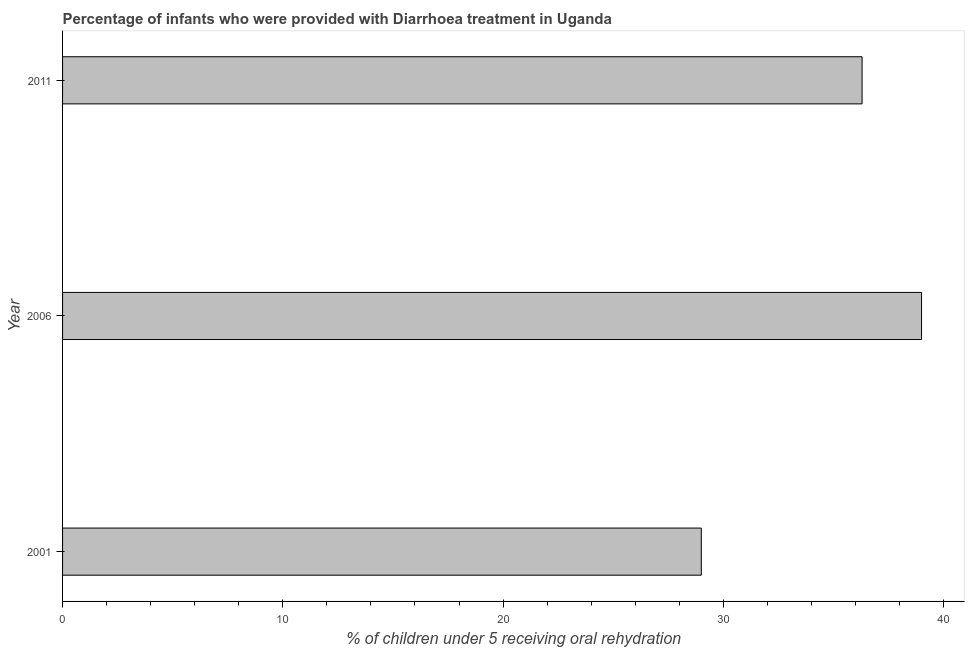Does the graph contain grids?
Offer a terse response. No. What is the title of the graph?
Keep it short and to the point. Percentage of infants who were provided with Diarrhoea treatment in Uganda. What is the label or title of the X-axis?
Offer a terse response. % of children under 5 receiving oral rehydration. In which year was the percentage of children who were provided with treatment diarrhoea maximum?
Provide a succinct answer. 2006. In which year was the percentage of children who were provided with treatment diarrhoea minimum?
Offer a terse response. 2001. What is the sum of the percentage of children who were provided with treatment diarrhoea?
Keep it short and to the point. 104.3. What is the average percentage of children who were provided with treatment diarrhoea per year?
Provide a succinct answer. 34.77. What is the median percentage of children who were provided with treatment diarrhoea?
Your answer should be compact. 36.3. What is the ratio of the percentage of children who were provided with treatment diarrhoea in 2001 to that in 2011?
Your answer should be very brief. 0.8. What is the difference between the highest and the second highest percentage of children who were provided with treatment diarrhoea?
Your answer should be compact. 2.7. Is the sum of the percentage of children who were provided with treatment diarrhoea in 2001 and 2006 greater than the maximum percentage of children who were provided with treatment diarrhoea across all years?
Your answer should be very brief. Yes. What is the difference between the highest and the lowest percentage of children who were provided with treatment diarrhoea?
Give a very brief answer. 10. In how many years, is the percentage of children who were provided with treatment diarrhoea greater than the average percentage of children who were provided with treatment diarrhoea taken over all years?
Ensure brevity in your answer.  2. How many bars are there?
Make the answer very short. 3. Are all the bars in the graph horizontal?
Ensure brevity in your answer.  Yes. How many years are there in the graph?
Your answer should be compact. 3. What is the difference between two consecutive major ticks on the X-axis?
Provide a short and direct response. 10. What is the % of children under 5 receiving oral rehydration of 2011?
Provide a short and direct response. 36.3. What is the difference between the % of children under 5 receiving oral rehydration in 2001 and 2006?
Provide a succinct answer. -10. What is the difference between the % of children under 5 receiving oral rehydration in 2001 and 2011?
Make the answer very short. -7.3. What is the difference between the % of children under 5 receiving oral rehydration in 2006 and 2011?
Offer a very short reply. 2.7. What is the ratio of the % of children under 5 receiving oral rehydration in 2001 to that in 2006?
Provide a short and direct response. 0.74. What is the ratio of the % of children under 5 receiving oral rehydration in 2001 to that in 2011?
Ensure brevity in your answer.  0.8. What is the ratio of the % of children under 5 receiving oral rehydration in 2006 to that in 2011?
Offer a terse response. 1.07. 